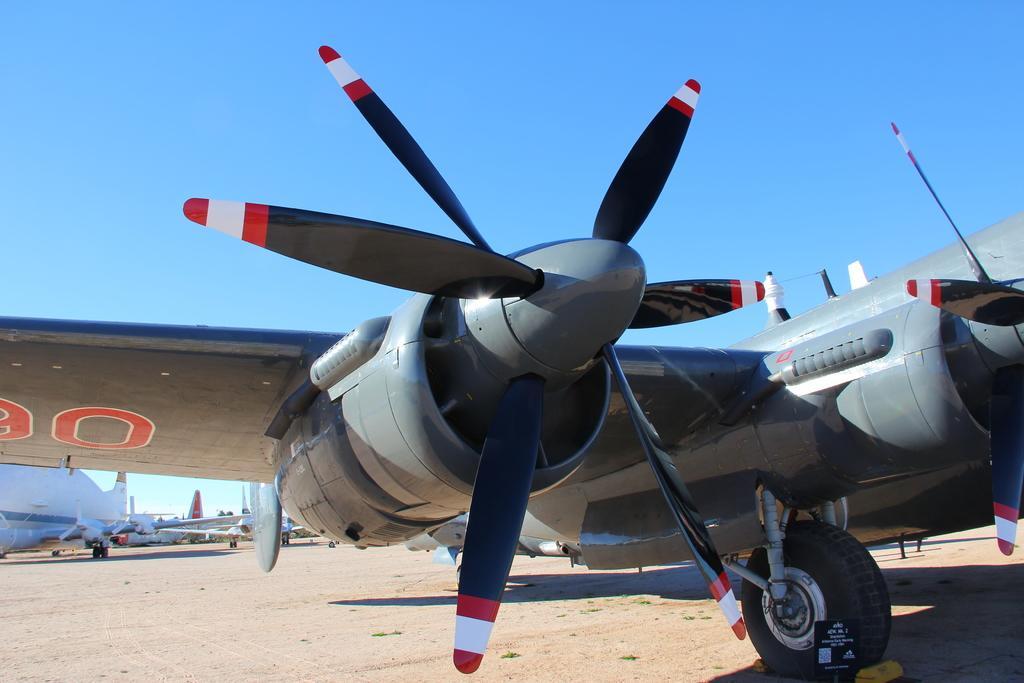In one or two sentences, can you explain what this image depicts? In front of the picture, we see an airplane which is grey in color on the runway. There are many airplanes in the background are on the runway. At the top of the picture, we see the sky, which is blue in color. 